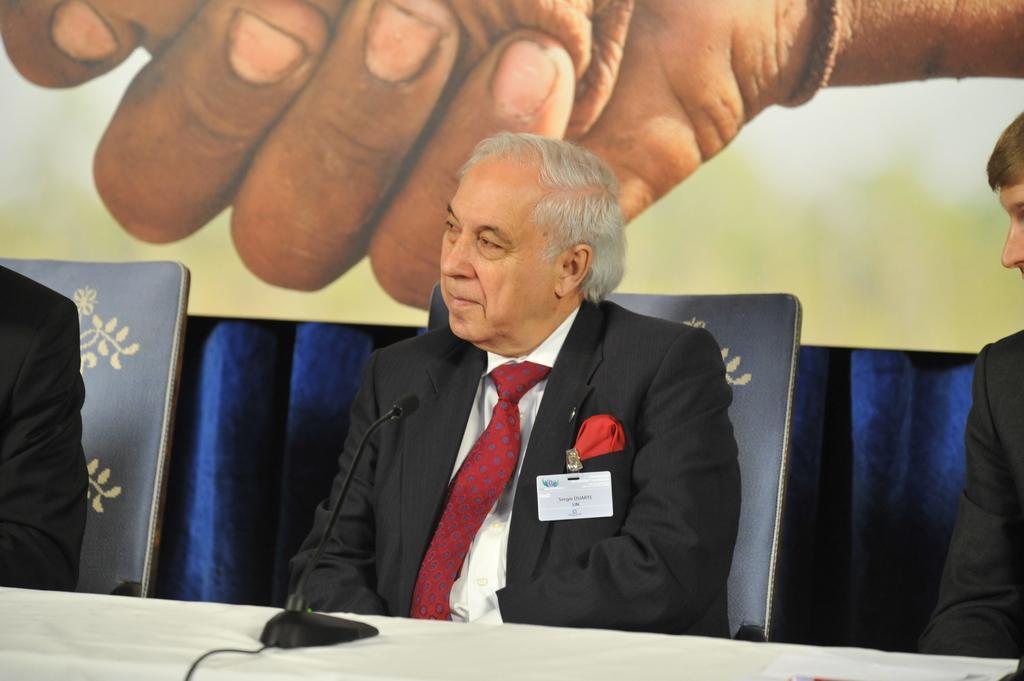How would you summarize this image in a sentence or two? In the foreground of the picture there are people, chairs, table, cable and an electronic gadget. In the background we can see banner and curtain. 